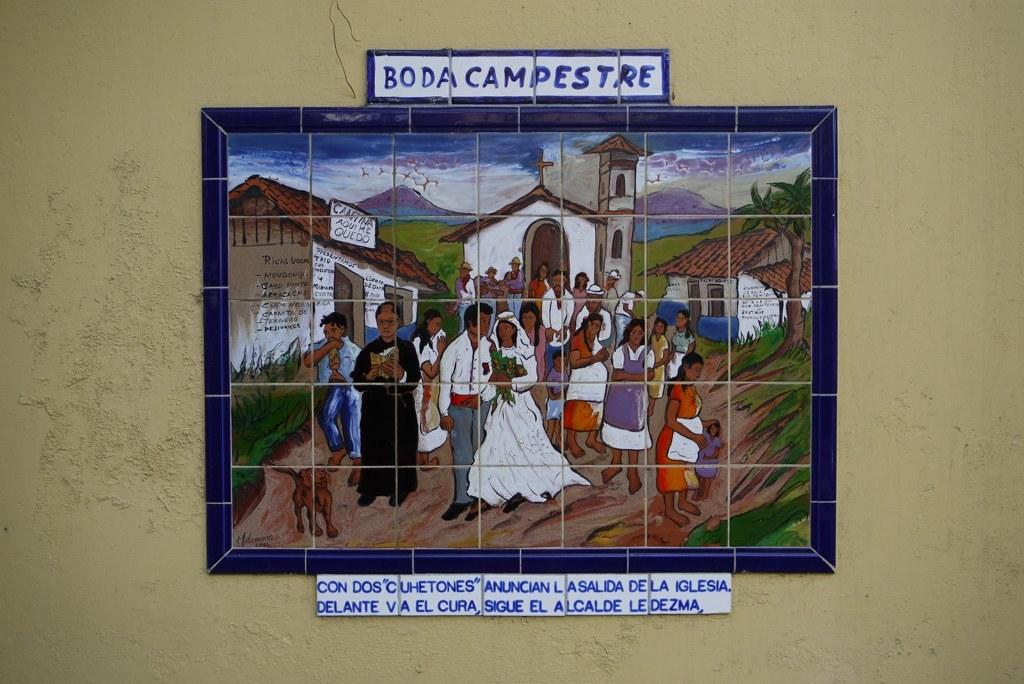<image>
Describe the image concisely. A picture in Spanish that is titled Boda Compestre 